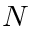Convert formula to latex. <formula><loc_0><loc_0><loc_500><loc_500>N</formula> 